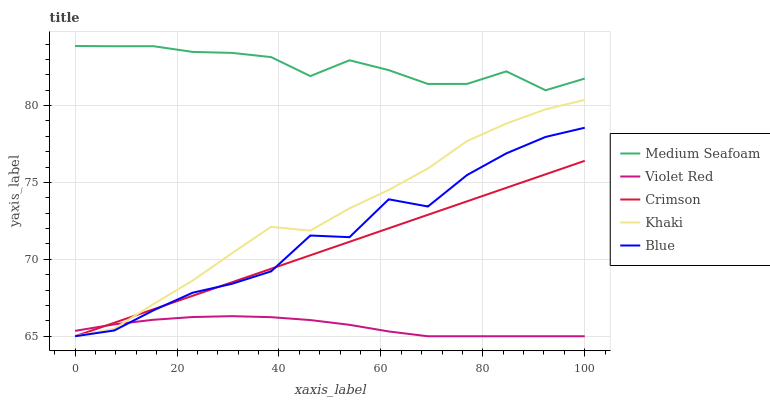Does Violet Red have the minimum area under the curve?
Answer yes or no. Yes. Does Medium Seafoam have the maximum area under the curve?
Answer yes or no. Yes. Does Blue have the minimum area under the curve?
Answer yes or no. No. Does Blue have the maximum area under the curve?
Answer yes or no. No. Is Crimson the smoothest?
Answer yes or no. Yes. Is Blue the roughest?
Answer yes or no. Yes. Is Violet Red the smoothest?
Answer yes or no. No. Is Violet Red the roughest?
Answer yes or no. No. Does Crimson have the lowest value?
Answer yes or no. Yes. Does Medium Seafoam have the lowest value?
Answer yes or no. No. Does Medium Seafoam have the highest value?
Answer yes or no. Yes. Does Blue have the highest value?
Answer yes or no. No. Is Khaki less than Medium Seafoam?
Answer yes or no. Yes. Is Medium Seafoam greater than Khaki?
Answer yes or no. Yes. Does Crimson intersect Blue?
Answer yes or no. Yes. Is Crimson less than Blue?
Answer yes or no. No. Is Crimson greater than Blue?
Answer yes or no. No. Does Khaki intersect Medium Seafoam?
Answer yes or no. No. 